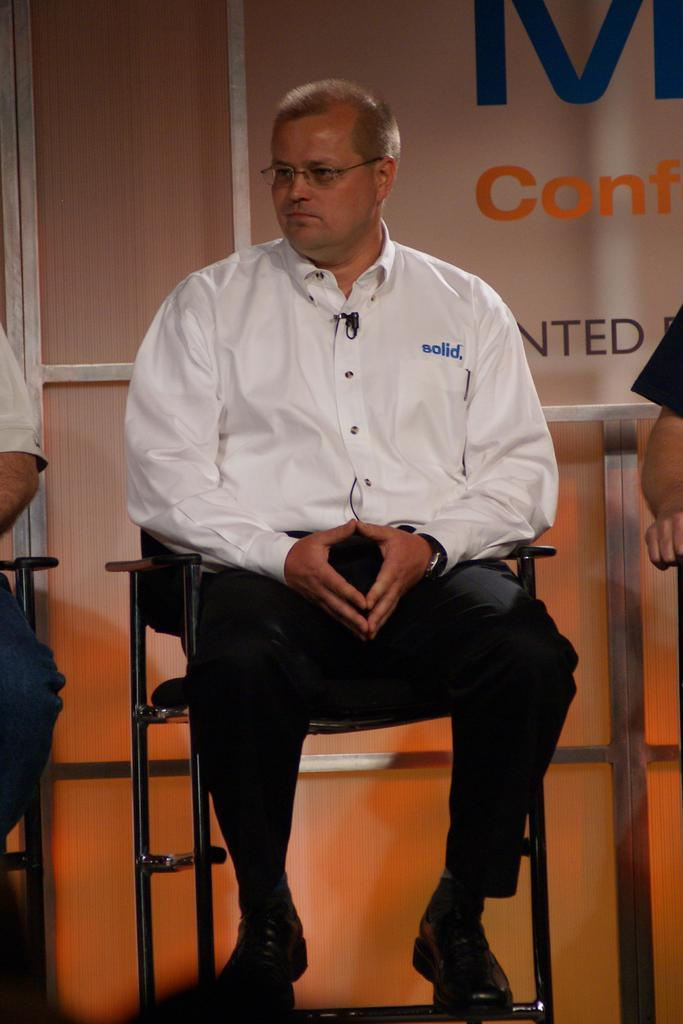How many people are in the image? There are three persons in the image. What are the persons doing in the image? The persons are sitting on chairs. What can be seen on a board in the image? There is a text on a board in the image. What is visible in the background of the image? There is a wall visible in the image. Can you see the moon in the image? No, the moon is not visible in the image. Are there any wrens present in the image? No, there are no wrens present in the image. 